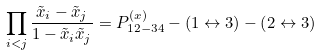Convert formula to latex. <formula><loc_0><loc_0><loc_500><loc_500>\prod _ { i < j } \frac { \tilde { x } _ { i } - \tilde { x } _ { j } } { 1 - \tilde { x } _ { i } \tilde { x } _ { j } } = P _ { 1 2 - 3 4 } ^ { ( x ) } - \left ( 1 \leftrightarrow 3 \right ) - \left ( 2 \leftrightarrow 3 \right )</formula> 